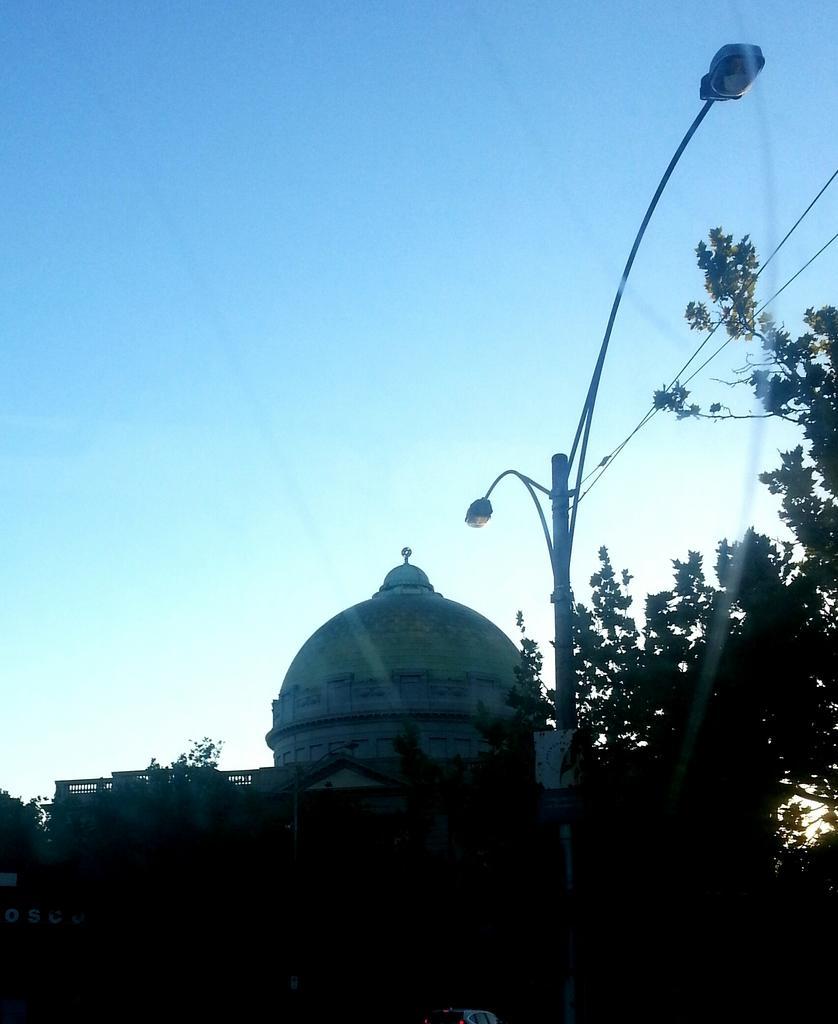Please provide a concise description of this image. In the center of the image there is a light pole. In the background of the image there is building and sky. There are trees. 